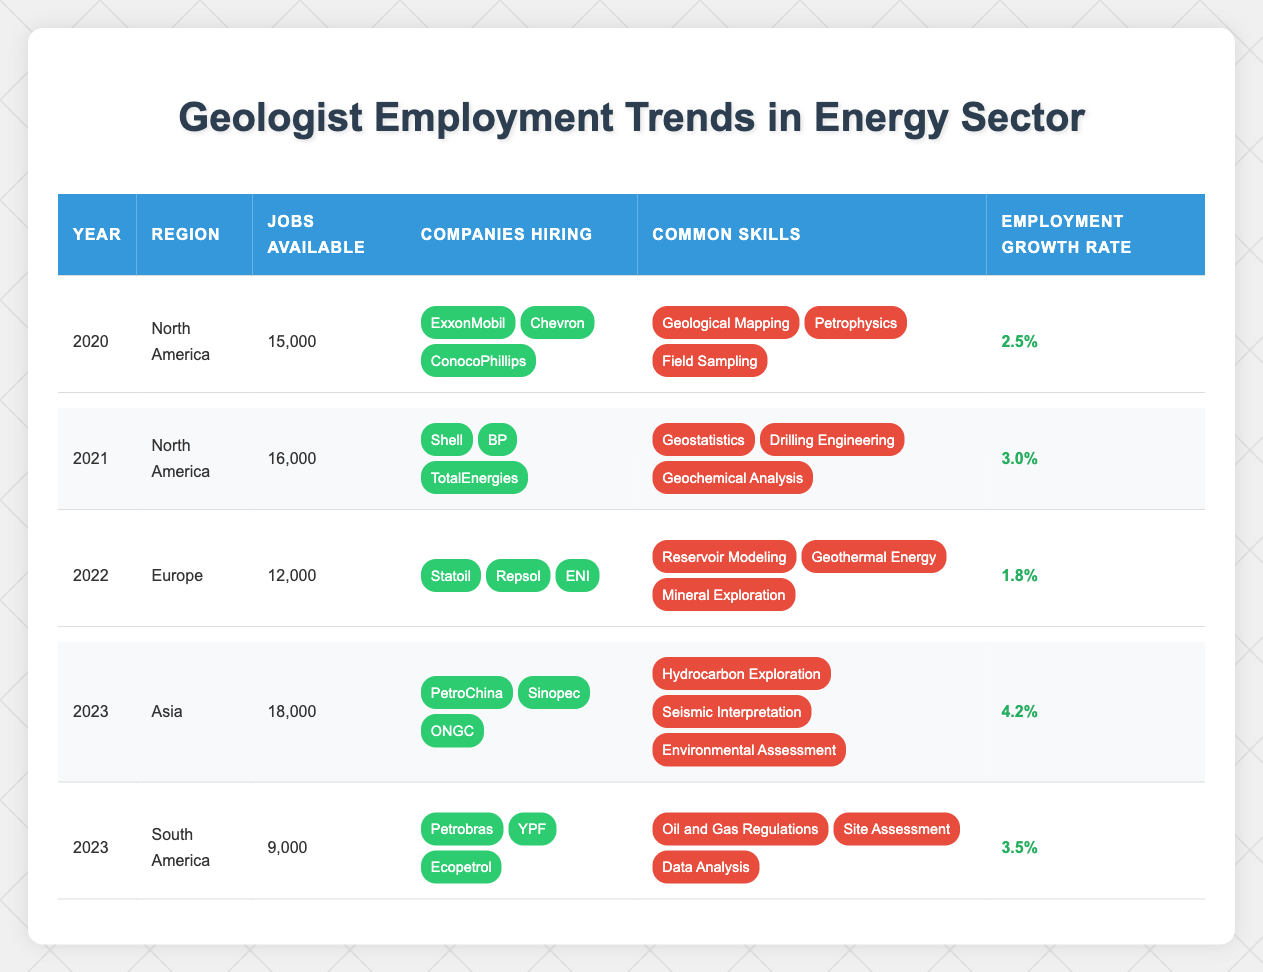What was the employment growth rate for geologists in North America in 2021? The table indicates that in 2021, the employment growth rate for geologists in North America was listed as 3.0%.
Answer: 3.0% Which region had the highest number of jobs available for geologists in 2023? In 2023, the table shows that Asia had the highest number of jobs available at 18,000 compared to other regions for that year.
Answer: Asia How many companies were hiring geologists in South America in 2023? The table lists three companies hiring geologists in South America in 2023: Petrobras, YPF, and Ecopetrol.
Answer: 3 What were the common skills required for geologists in Europe in 2022? The common skills listed for geologists in Europe in 2022 include Reservoir Modeling, Geothermal Energy, and Mineral Exploration.
Answer: Reservoir Modeling, Geothermal Energy, Mineral Exploration What is the total number of jobs available for geologists across all regions in 2023? To find the total, we sum the jobs available: Asia (18,000) + South America (9,000) = 27,000.
Answer: 27,000 Was there an increase or decrease in the employment growth rate for geologists in North America from 2020 to 2021? The growth rate in 2020 was 2.5%, and in 2021 it increased to 3.0%, indicating an increase.
Answer: Increase Calculate the average number of jobs available for geologists across all years in the table. The jobs available are: 15,000 (2020) + 16,000 (2021) + 12,000 (2022) + 18,000 (2023 - Asia) + 9,000 (2023 - South America) = 70,000. There are 5 years, so the average is 70,000 / 5 = 14,000.
Answer: 14,000 Which region employed the least number of geologists in 2022? The table shows that in 2022, Europe had the least number of jobs available for geologists at 12,000.
Answer: Europe Were any companies hiring for geologists in both North America in 2020 and 2021? The companies in 2020 (ExxonMobil, Chevron, ConocoPhillips) and 2021 (Shell, BP, TotalEnergies) differ, indicating that no companies were hiring in both years for North America.
Answer: No What was the common skill required for geologists in Asia in 2023? In Asia in 2023, the common skills include Hydrocarbon Exploration, Seismic Interpretation, and Environmental Assessment.
Answer: Hydrocarbon Exploration, Seismic Interpretation, Environmental Assessment 